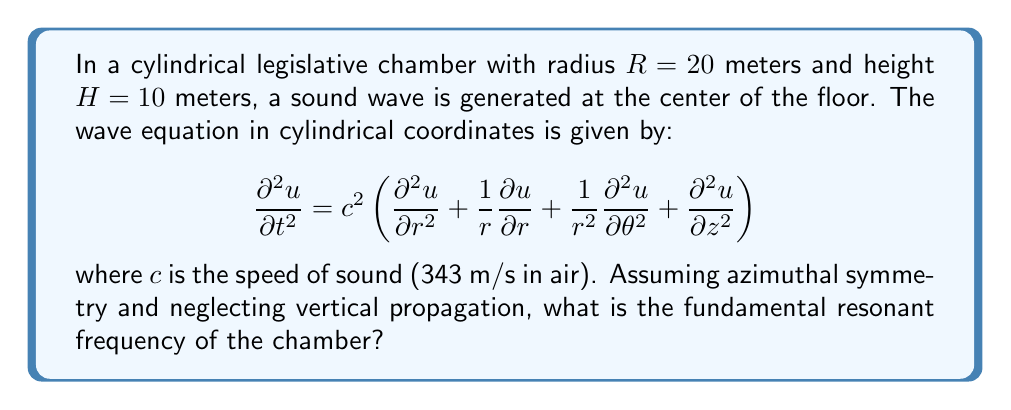Could you help me with this problem? To solve this problem, we'll follow these steps:

1) Given the azimuthal symmetry and neglecting vertical propagation, we can simplify the wave equation to:

   $$\frac{\partial^2 u}{\partial t^2} = c^2 \left(\frac{\partial^2 u}{\partial r^2} + \frac{1}{r}\frac{\partial u}{\partial r}\right)$$

2) For a cylindrical chamber, the solution to this equation takes the form:

   $$u(r,t) = J_0(kr)\cos(\omega t)$$

   where $J_0$ is the Bessel function of the first kind of order zero, $k$ is the wavenumber, and $\omega$ is the angular frequency.

3) The boundary condition for a rigid wall at $r=R$ is:

   $$\left.\frac{\partial u}{\partial r}\right|_{r=R} = 0$$

4) This condition is satisfied when:

   $$kR = \alpha_{0,n}$$

   where $\alpha_{0,n}$ is the $n$th zero of the derivative of $J_0$.

5) The fundamental mode corresponds to $n=1$, and $\alpha_{0,1} \approx 3.8317$.

6) The wavenumber $k$ is related to the frequency $f$ by:

   $$k = \frac{2\pi f}{c}$$

7) Substituting this into the condition from step 4:

   $$\frac{2\pi f R}{c} = 3.8317$$

8) Solving for $f$:

   $$f = \frac{3.8317 c}{2\pi R}$$

9) Plugging in the values:

   $$f = \frac{3.8317 \cdot 343}{2\pi \cdot 20} \approx 10.46 \text{ Hz}$$
Answer: 10.46 Hz 